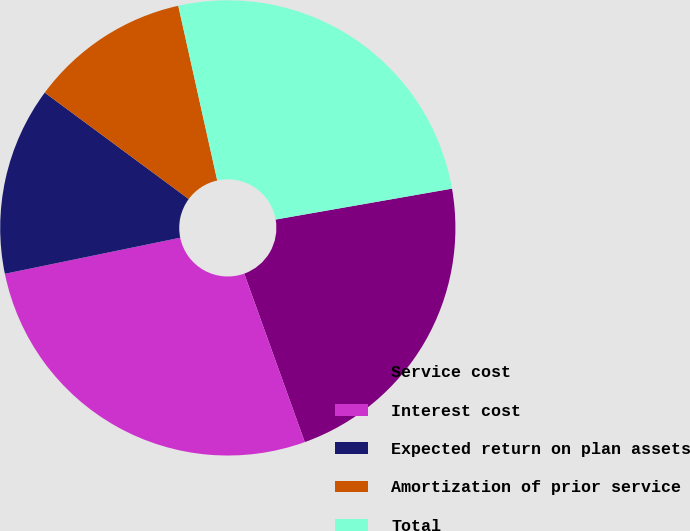Convert chart. <chart><loc_0><loc_0><loc_500><loc_500><pie_chart><fcel>Service cost<fcel>Interest cost<fcel>Expected return on plan assets<fcel>Amortization of prior service<fcel>Total<nl><fcel>22.27%<fcel>27.26%<fcel>13.36%<fcel>11.38%<fcel>25.73%<nl></chart> 